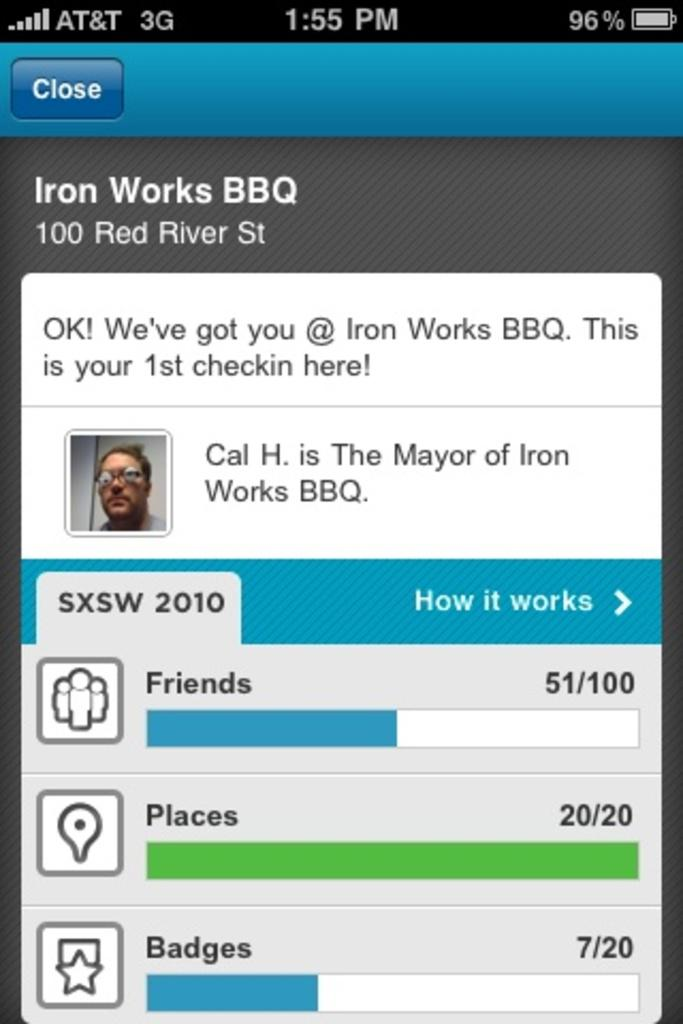What is the main object in the image? There is a screen in the image. What can be seen on the screen? A person is visible on the screen, along with symbols and text. How many cherries are on the land in the image? There are no cherries or land present in the image; it only features a screen with a person, symbols, and text. 